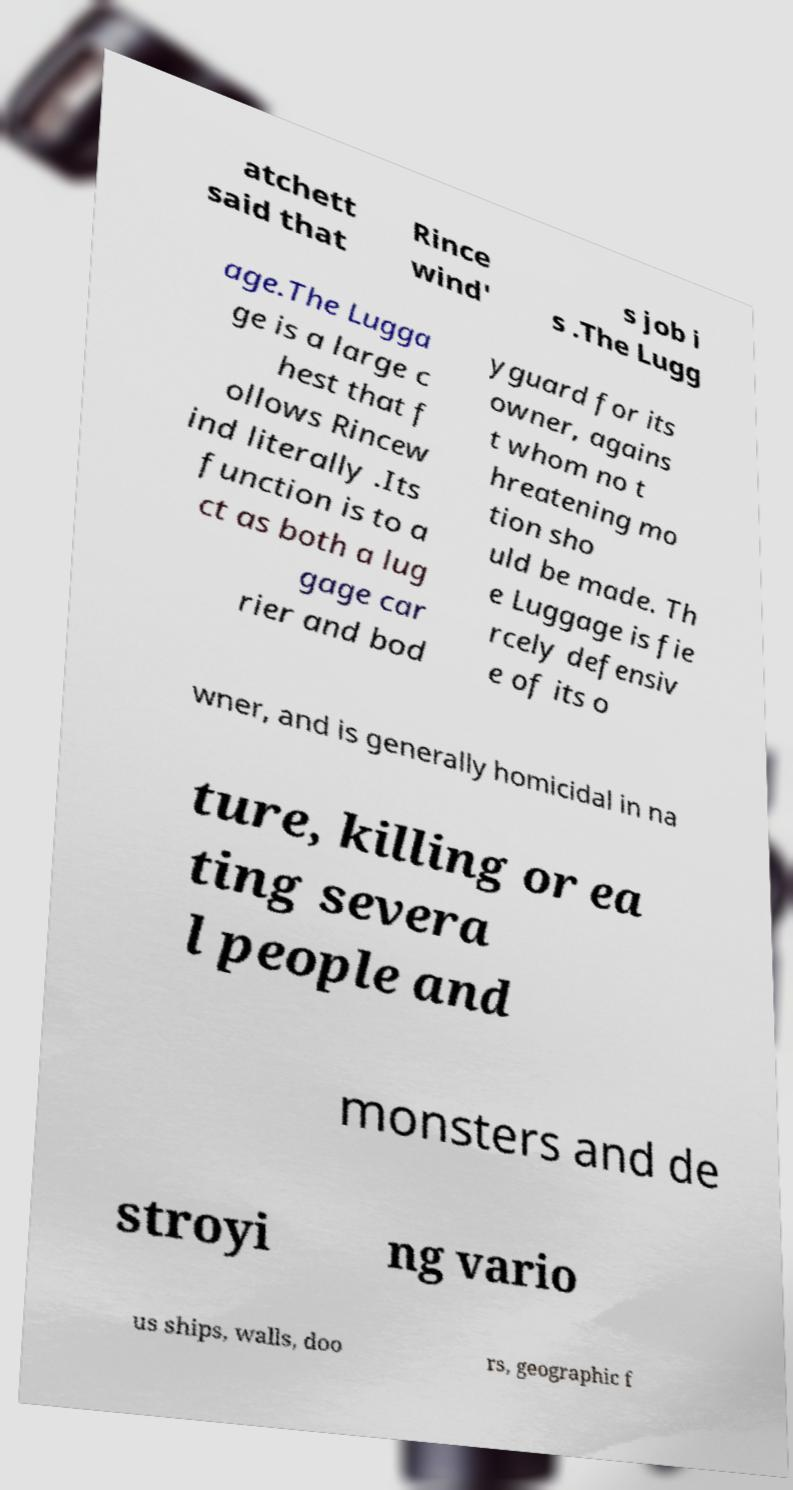Could you extract and type out the text from this image? atchett said that Rince wind' s job i s .The Lugg age.The Lugga ge is a large c hest that f ollows Rincew ind literally .Its function is to a ct as both a lug gage car rier and bod yguard for its owner, agains t whom no t hreatening mo tion sho uld be made. Th e Luggage is fie rcely defensiv e of its o wner, and is generally homicidal in na ture, killing or ea ting severa l people and monsters and de stroyi ng vario us ships, walls, doo rs, geographic f 